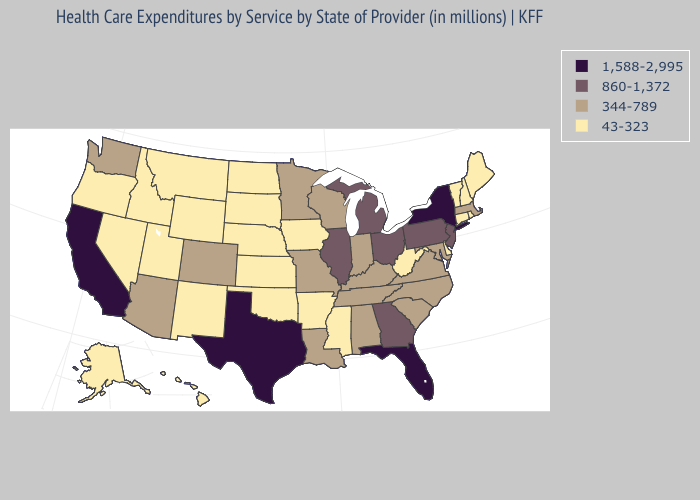Which states have the lowest value in the West?
Give a very brief answer. Alaska, Hawaii, Idaho, Montana, Nevada, New Mexico, Oregon, Utah, Wyoming. Does Montana have a higher value than California?
Concise answer only. No. What is the lowest value in the MidWest?
Keep it brief. 43-323. Name the states that have a value in the range 43-323?
Quick response, please. Alaska, Arkansas, Connecticut, Delaware, Hawaii, Idaho, Iowa, Kansas, Maine, Mississippi, Montana, Nebraska, Nevada, New Hampshire, New Mexico, North Dakota, Oklahoma, Oregon, Rhode Island, South Dakota, Utah, Vermont, West Virginia, Wyoming. What is the highest value in the MidWest ?
Answer briefly. 860-1,372. Name the states that have a value in the range 860-1,372?
Answer briefly. Georgia, Illinois, Michigan, New Jersey, Ohio, Pennsylvania. Does Maryland have the lowest value in the South?
Keep it brief. No. Which states have the highest value in the USA?
Concise answer only. California, Florida, New York, Texas. Which states hav the highest value in the Northeast?
Answer briefly. New York. Which states hav the highest value in the South?
Keep it brief. Florida, Texas. Is the legend a continuous bar?
Keep it brief. No. Name the states that have a value in the range 43-323?
Give a very brief answer. Alaska, Arkansas, Connecticut, Delaware, Hawaii, Idaho, Iowa, Kansas, Maine, Mississippi, Montana, Nebraska, Nevada, New Hampshire, New Mexico, North Dakota, Oklahoma, Oregon, Rhode Island, South Dakota, Utah, Vermont, West Virginia, Wyoming. Does the map have missing data?
Write a very short answer. No. What is the lowest value in the West?
Give a very brief answer. 43-323. Among the states that border North Dakota , which have the highest value?
Be succinct. Minnesota. 